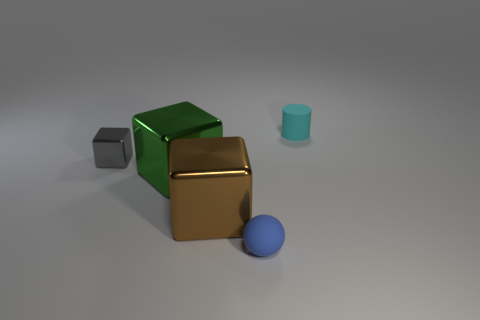Can you describe the lighting in the scene? The lighting in the scene seems to be diffused with soft shadows, indicating there may be a broad light source above the objects, creating a calm and evenly lit atmosphere. 